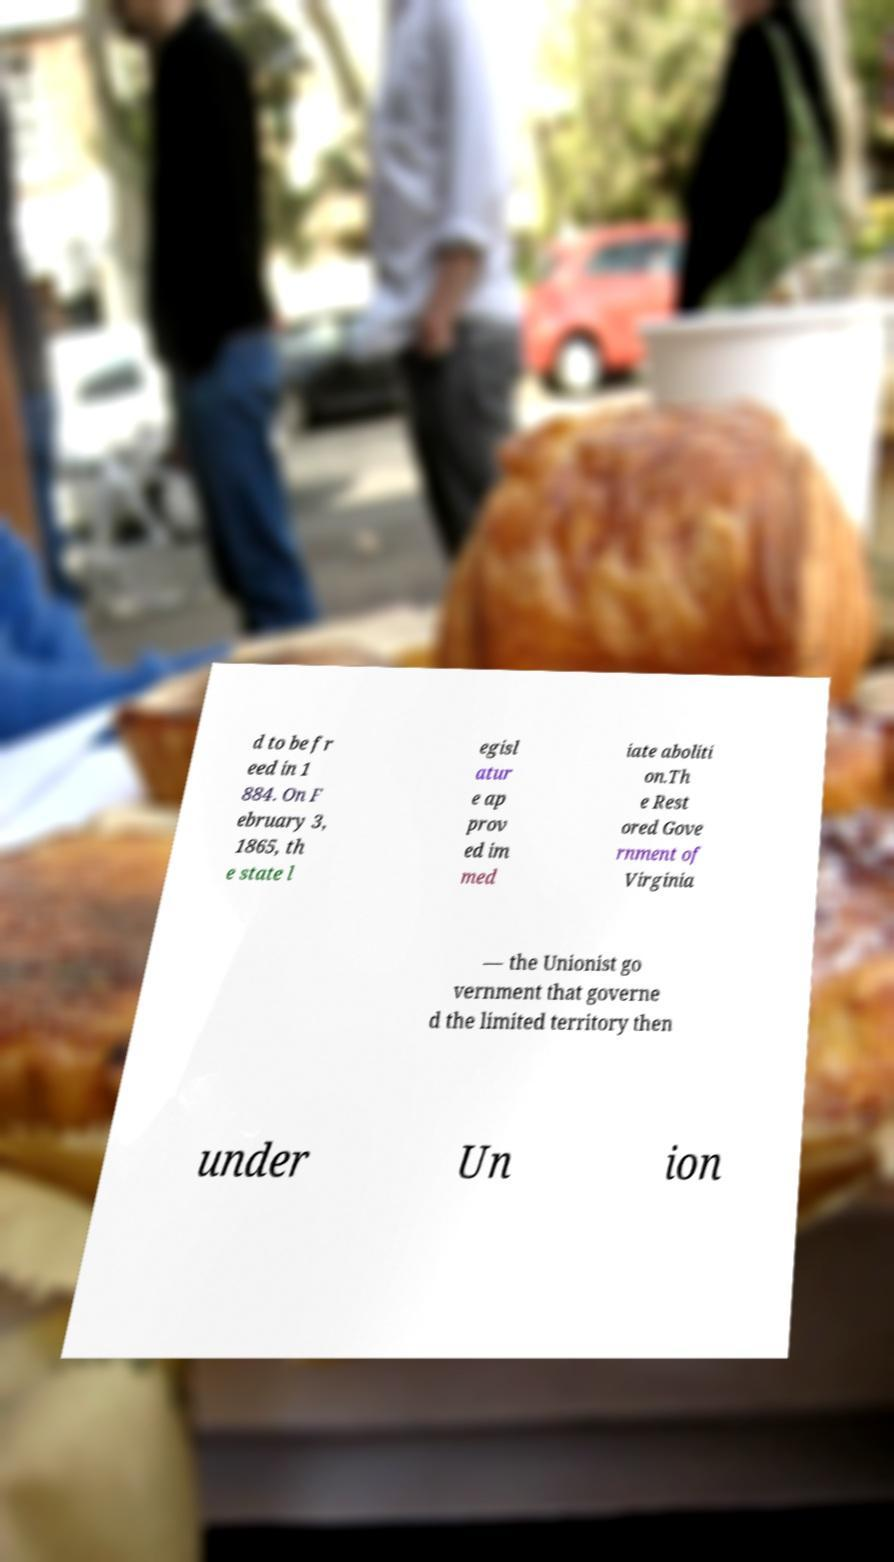What messages or text are displayed in this image? I need them in a readable, typed format. d to be fr eed in 1 884. On F ebruary 3, 1865, th e state l egisl atur e ap prov ed im med iate aboliti on.Th e Rest ored Gove rnment of Virginia — the Unionist go vernment that governe d the limited territory then under Un ion 